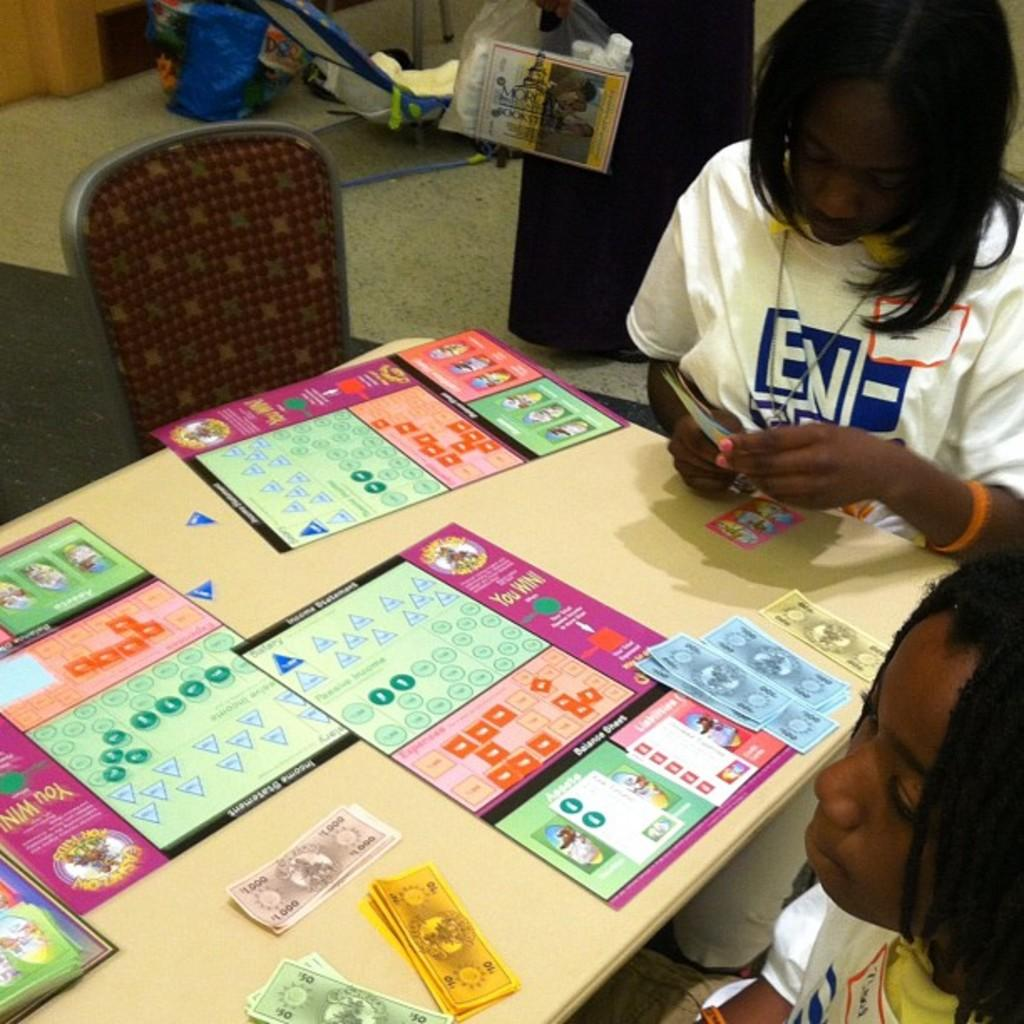What is on the table in the image? There are colorful papers on the table. How many kids are in the image? There are two kids in the image. What is one of the kids doing with a paper? One kid is holding a paper. What type of furniture is present in the image? There are chairs in the image. What is on the floor in the image? There are objects on the floor. Can you tell me how many roads are visible in the image? There are no roads visible in the image. What type of seat is the kid using to hold the paper? The kid is not using a seat to hold the paper; they are simply holding it in their hand. 